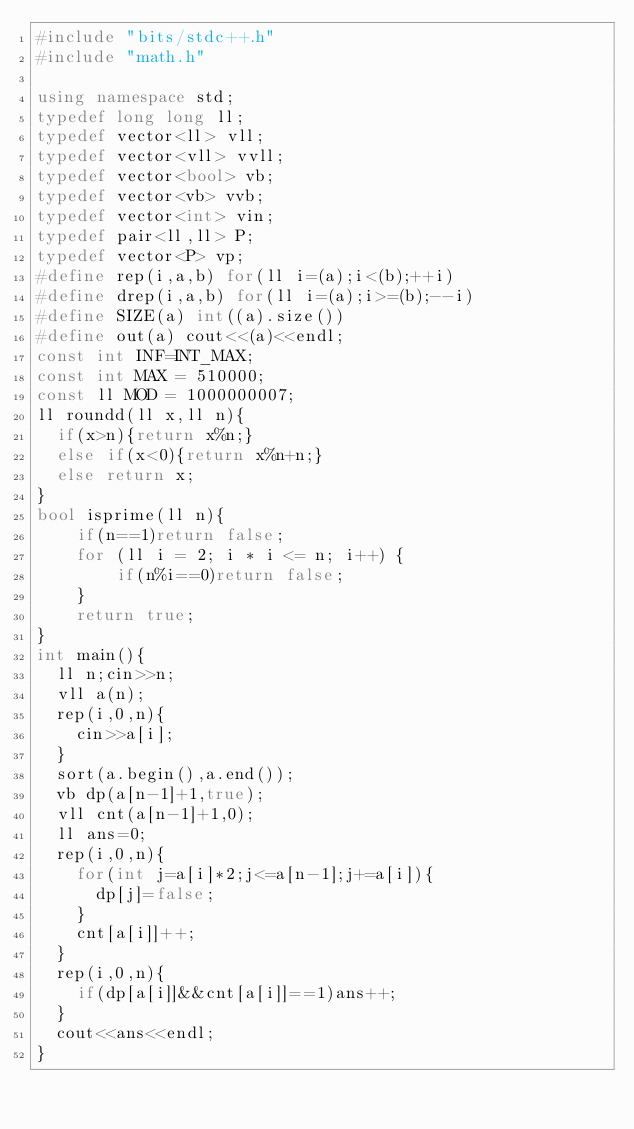<code> <loc_0><loc_0><loc_500><loc_500><_C++_>#include "bits/stdc++.h"
#include "math.h"
 
using namespace std;
typedef long long ll;
typedef vector<ll> vll;
typedef vector<vll> vvll;
typedef vector<bool> vb;
typedef vector<vb> vvb;
typedef vector<int> vin;
typedef pair<ll,ll> P;
typedef vector<P> vp;
#define rep(i,a,b) for(ll i=(a);i<(b);++i)
#define drep(i,a,b) for(ll i=(a);i>=(b);--i)
#define SIZE(a) int((a).size())
#define out(a) cout<<(a)<<endl;
const int INF=INT_MAX;
const int MAX = 510000;
const ll MOD = 1000000007;
ll roundd(ll x,ll n){
  if(x>n){return x%n;}
  else if(x<0){return x%n+n;}
  else return x;
}
bool isprime(ll n){
    if(n==1)return false;
    for (ll i = 2; i * i <= n; i++) {
        if(n%i==0)return false;
    }
    return true;
}
int main(){
  ll n;cin>>n;
  vll a(n);
  rep(i,0,n){
    cin>>a[i];
  }
  sort(a.begin(),a.end());
  vb dp(a[n-1]+1,true);
  vll cnt(a[n-1]+1,0);
  ll ans=0;
  rep(i,0,n){
    for(int j=a[i]*2;j<=a[n-1];j+=a[i]){
      dp[j]=false;
    }
    cnt[a[i]]++;
  }
  rep(i,0,n){
    if(dp[a[i]]&&cnt[a[i]]==1)ans++;
  }
  cout<<ans<<endl;
}

</code> 